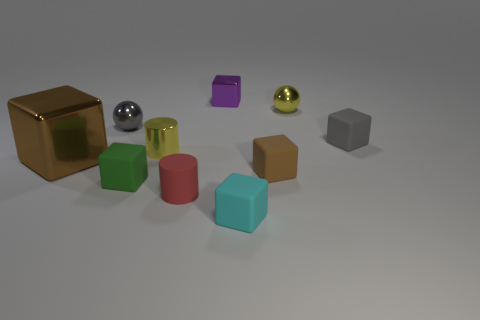Is there anything else that has the same size as the brown metal object?
Your answer should be compact. No. There is a yellow metallic thing right of the cyan matte block; is its shape the same as the small gray metallic object?
Your response must be concise. Yes. Are there fewer large metallic objects to the right of the tiny yellow metallic cylinder than big blue matte cubes?
Provide a short and direct response. No. Is there a tiny purple object made of the same material as the tiny yellow sphere?
Ensure brevity in your answer.  Yes. There is a yellow cylinder that is the same size as the green object; what is its material?
Keep it short and to the point. Metal. Is the number of small yellow metal objects that are in front of the gray rubber thing less than the number of rubber blocks that are right of the small green block?
Your answer should be very brief. Yes. There is a shiny object that is both on the left side of the green matte cube and in front of the gray shiny thing; what shape is it?
Ensure brevity in your answer.  Cube. What number of yellow metal things have the same shape as the gray shiny object?
Give a very brief answer. 1. The green cube that is made of the same material as the tiny cyan block is what size?
Your response must be concise. Small. Is the number of shiny objects greater than the number of small brown cubes?
Offer a terse response. Yes. 